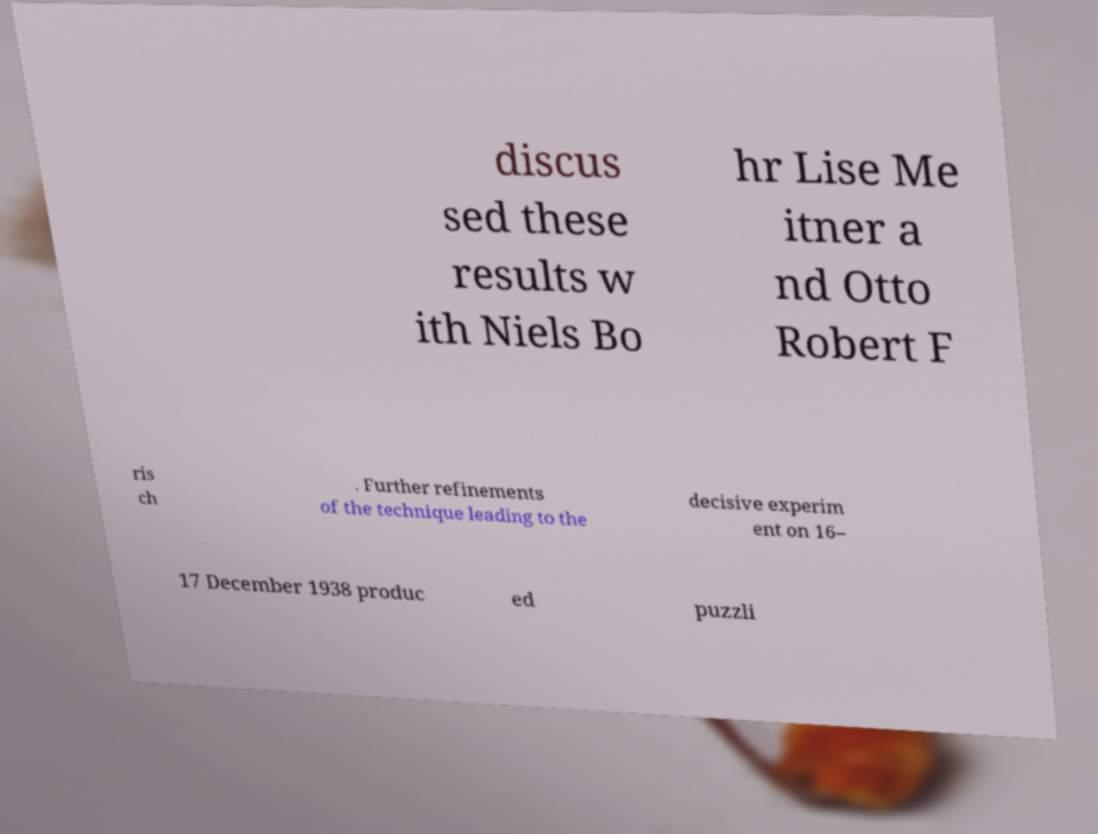Can you accurately transcribe the text from the provided image for me? discus sed these results w ith Niels Bo hr Lise Me itner a nd Otto Robert F ris ch . Further refinements of the technique leading to the decisive experim ent on 16– 17 December 1938 produc ed puzzli 